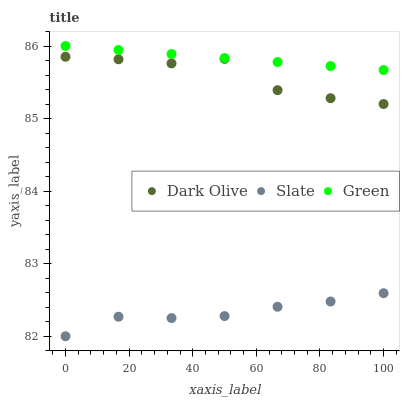Does Slate have the minimum area under the curve?
Answer yes or no. Yes. Does Green have the maximum area under the curve?
Answer yes or no. Yes. Does Dark Olive have the minimum area under the curve?
Answer yes or no. No. Does Dark Olive have the maximum area under the curve?
Answer yes or no. No. Is Green the smoothest?
Answer yes or no. Yes. Is Dark Olive the roughest?
Answer yes or no. Yes. Is Dark Olive the smoothest?
Answer yes or no. No. Is Green the roughest?
Answer yes or no. No. Does Slate have the lowest value?
Answer yes or no. Yes. Does Dark Olive have the lowest value?
Answer yes or no. No. Does Green have the highest value?
Answer yes or no. Yes. Does Dark Olive have the highest value?
Answer yes or no. No. Is Slate less than Green?
Answer yes or no. Yes. Is Dark Olive greater than Slate?
Answer yes or no. Yes. Does Slate intersect Green?
Answer yes or no. No. 